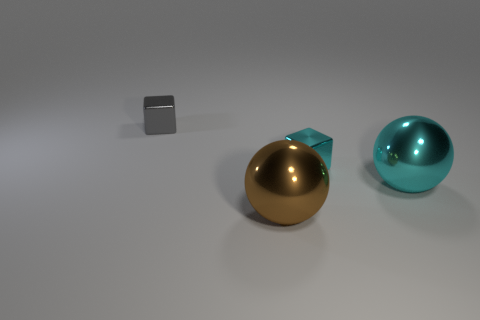Is there anything that denotes these objects might be part of a bigger picture? Without additional context, these objects could be part of a minimalist art installation, a product display, or a computer graphics rendering test. The way they are arranged and lit implies a purposeful composition aimed at focusing on form, color, and texture, possibly intended to evoke a sense of balance and simplicity.  What can you infer about the texture and material of these objects? The small cube appears to have a matte or slightly rough surface, which scatters light and gives it a soft visual texture. The two spheres have glossy, reflective surfaces, suggesting they are made of smooth, polished materials like metal or glass. Their reflections and highlights indicate that these materials are highly specular, allowing them to act as a mirror to their surroundings and create distinct, crisp reflections. 